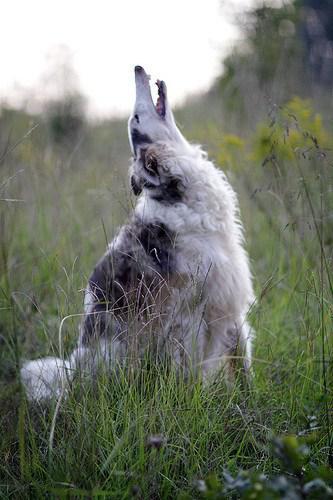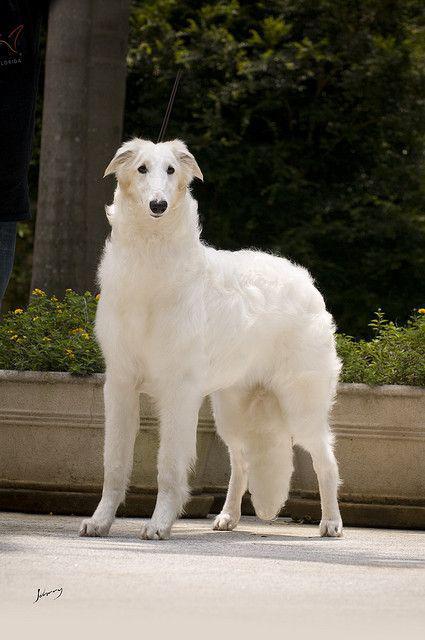The first image is the image on the left, the second image is the image on the right. Assess this claim about the two images: "There is only one dog in each picture.". Correct or not? Answer yes or no. Yes. 